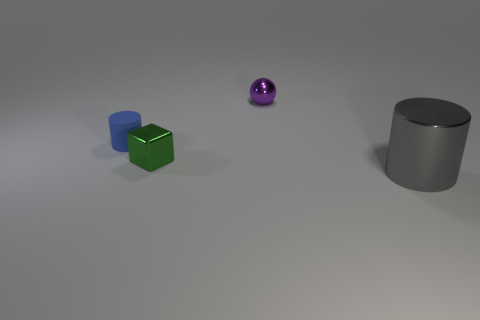Is there any other thing that has the same size as the metal cylinder?
Your answer should be compact. No. Is there any other thing that is made of the same material as the small cylinder?
Your response must be concise. No. Is there anything else that is the same shape as the green thing?
Provide a succinct answer. No. How many tiny green objects are on the right side of the cylinder that is left of the gray metallic cylinder?
Make the answer very short. 1. Is the cylinder that is behind the metal cylinder made of the same material as the tiny cube?
Your response must be concise. No. Are the cylinder behind the large gray cylinder and the cylinder that is on the right side of the purple metallic sphere made of the same material?
Your response must be concise. No. Is the number of big things behind the tiny shiny cube greater than the number of gray metallic cylinders?
Give a very brief answer. No. There is a cylinder in front of the shiny thing that is on the left side of the small purple metallic object; what is its color?
Offer a terse response. Gray. There is a purple shiny thing that is the same size as the metallic cube; what shape is it?
Make the answer very short. Sphere. Are there the same number of gray cylinders that are on the right side of the small blue object and small things?
Give a very brief answer. No. 